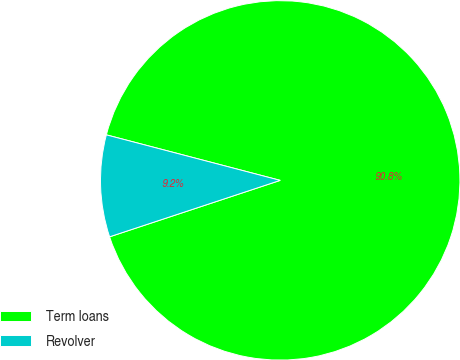Convert chart. <chart><loc_0><loc_0><loc_500><loc_500><pie_chart><fcel>Term loans<fcel>Revolver<nl><fcel>90.84%<fcel>9.16%<nl></chart> 